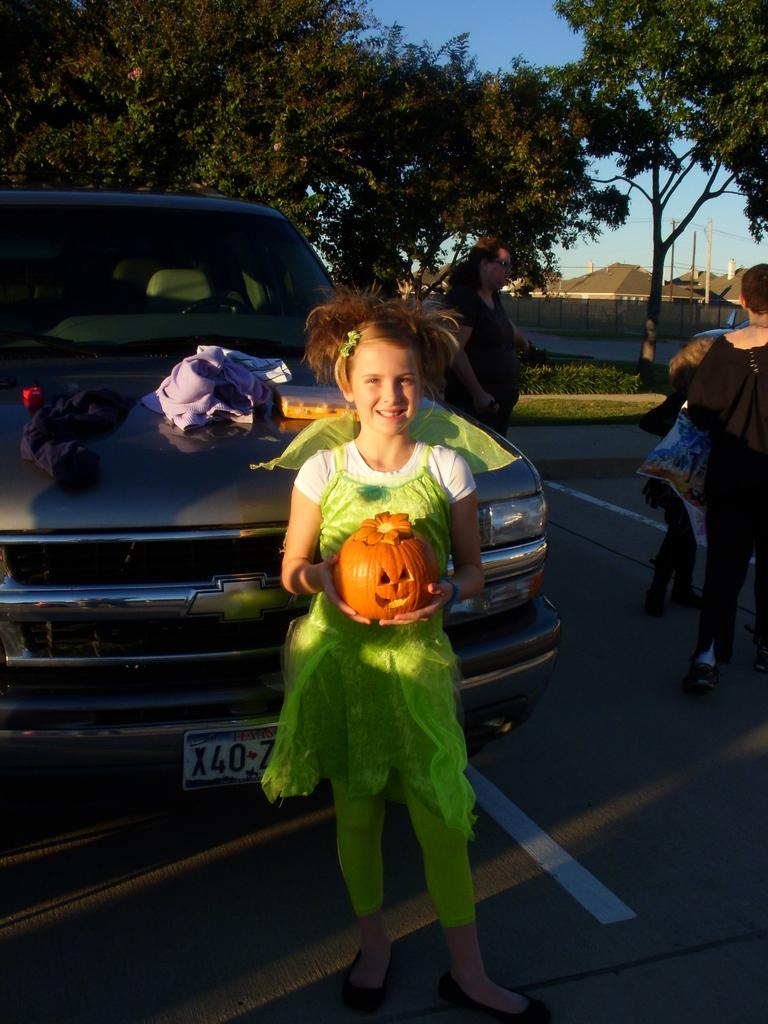Who is the main subject in the image? There is a girl in the image. What is the girl doing in the image? The girl is standing. What is the girl wearing in the image? The girl is wearing a green dress. What can be seen behind the girl in the image? There is a car behind the girl. What type of vegetation is visible in the image? There are trees on the back side of the image. What type of nose can be seen on the clover in the image? There is no clover present in the image, and therefore no nose can be observed. 